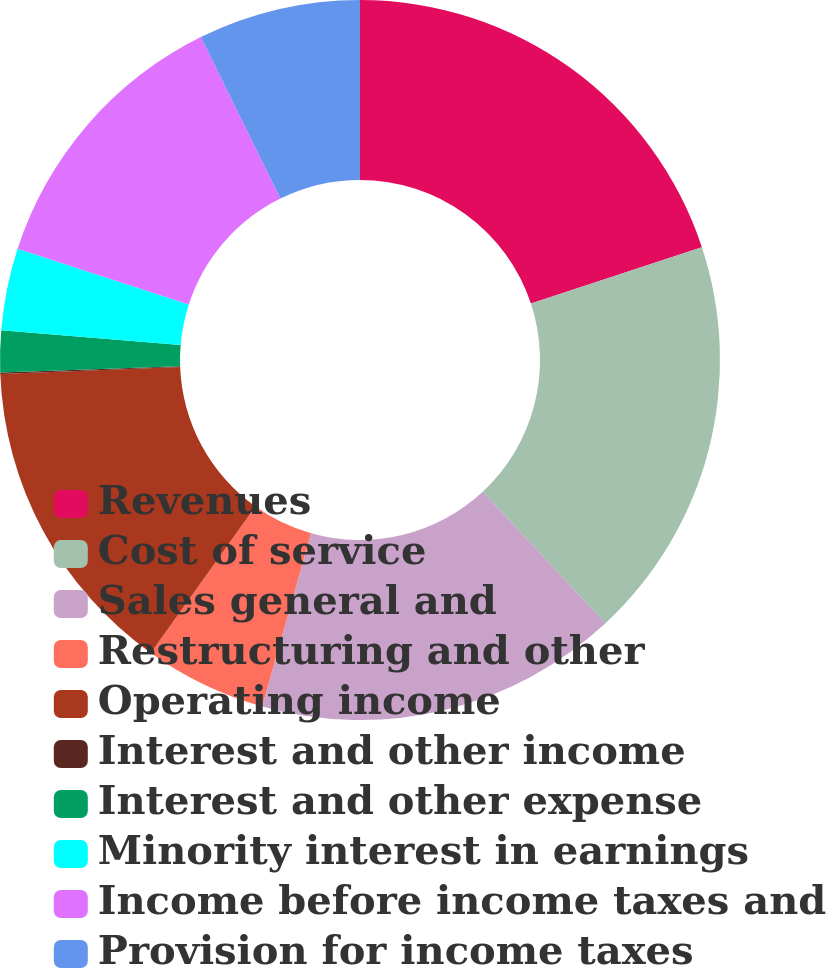<chart> <loc_0><loc_0><loc_500><loc_500><pie_chart><fcel>Revenues<fcel>Cost of service<fcel>Sales general and<fcel>Restructuring and other<fcel>Operating income<fcel>Interest and other income<fcel>Interest and other expense<fcel>Minority interest in earnings<fcel>Income before income taxes and<fcel>Provision for income taxes<nl><fcel>19.93%<fcel>18.13%<fcel>16.32%<fcel>5.49%<fcel>14.51%<fcel>0.07%<fcel>1.87%<fcel>3.68%<fcel>12.71%<fcel>7.29%<nl></chart> 